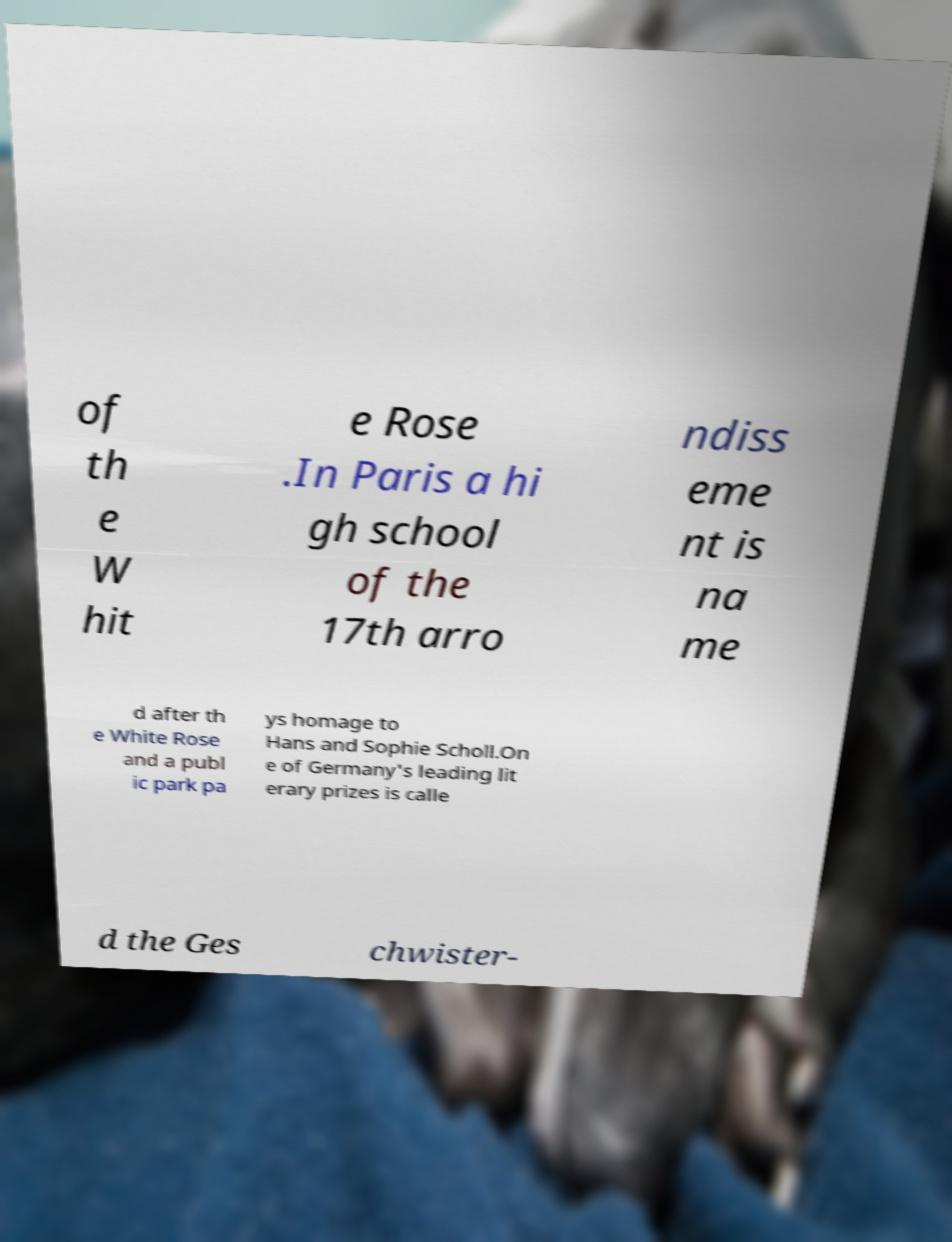Could you assist in decoding the text presented in this image and type it out clearly? of th e W hit e Rose .In Paris a hi gh school of the 17th arro ndiss eme nt is na me d after th e White Rose and a publ ic park pa ys homage to Hans and Sophie Scholl.On e of Germany's leading lit erary prizes is calle d the Ges chwister- 